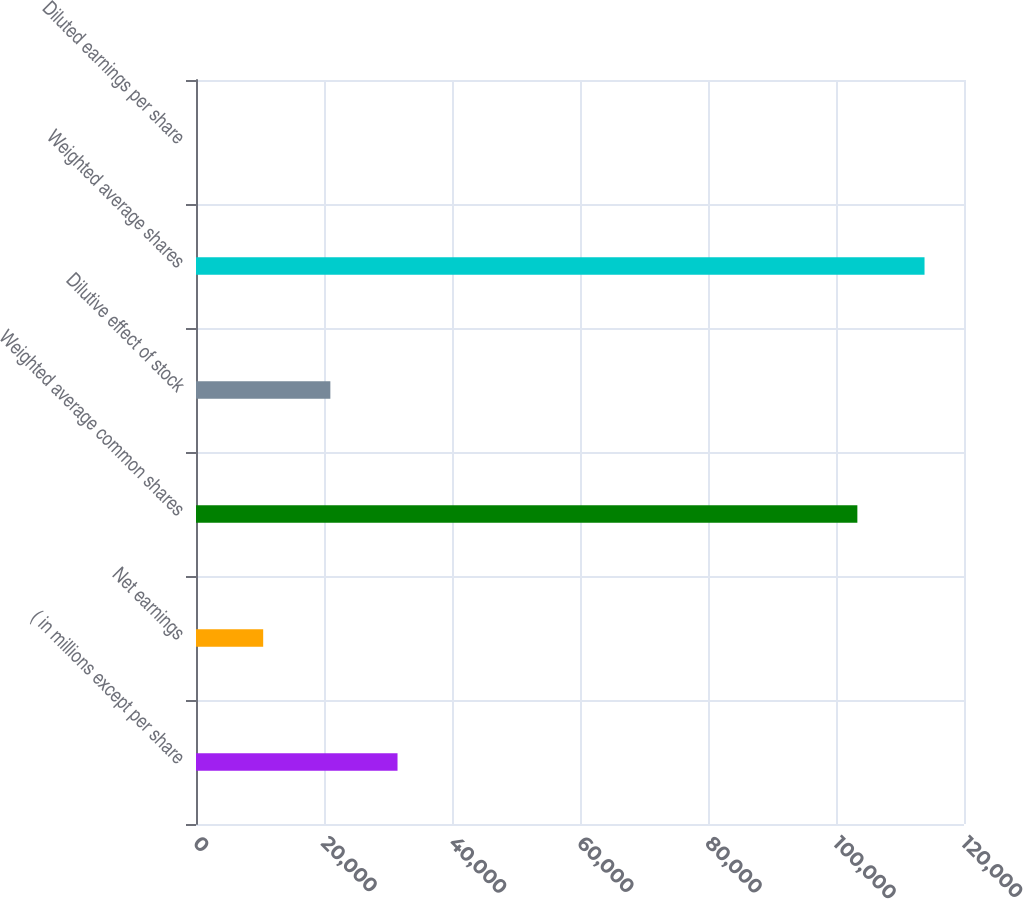<chart> <loc_0><loc_0><loc_500><loc_500><bar_chart><fcel>( in millions except per share<fcel>Net earnings<fcel>Weighted average common shares<fcel>Dilutive effect of stock<fcel>Weighted average shares<fcel>Diluted earnings per share<nl><fcel>31487.5<fcel>10497.9<fcel>103338<fcel>20992.7<fcel>113833<fcel>3.14<nl></chart> 